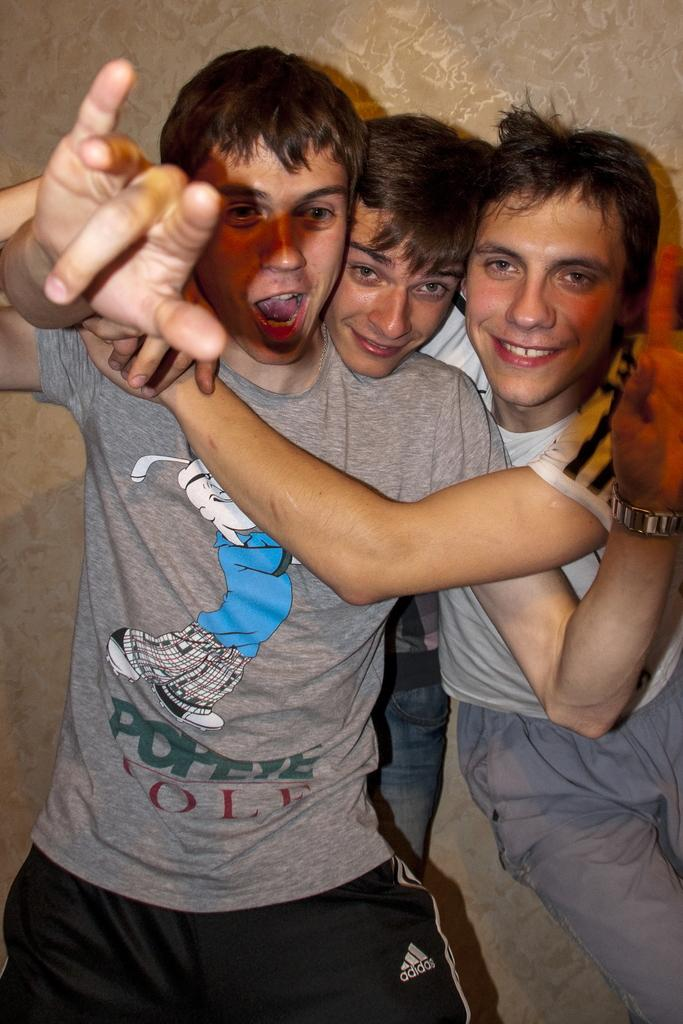<image>
Write a terse but informative summary of the picture. Three boys are pictured hugging each other with the boy in front wearing a popeye golf shirt. 